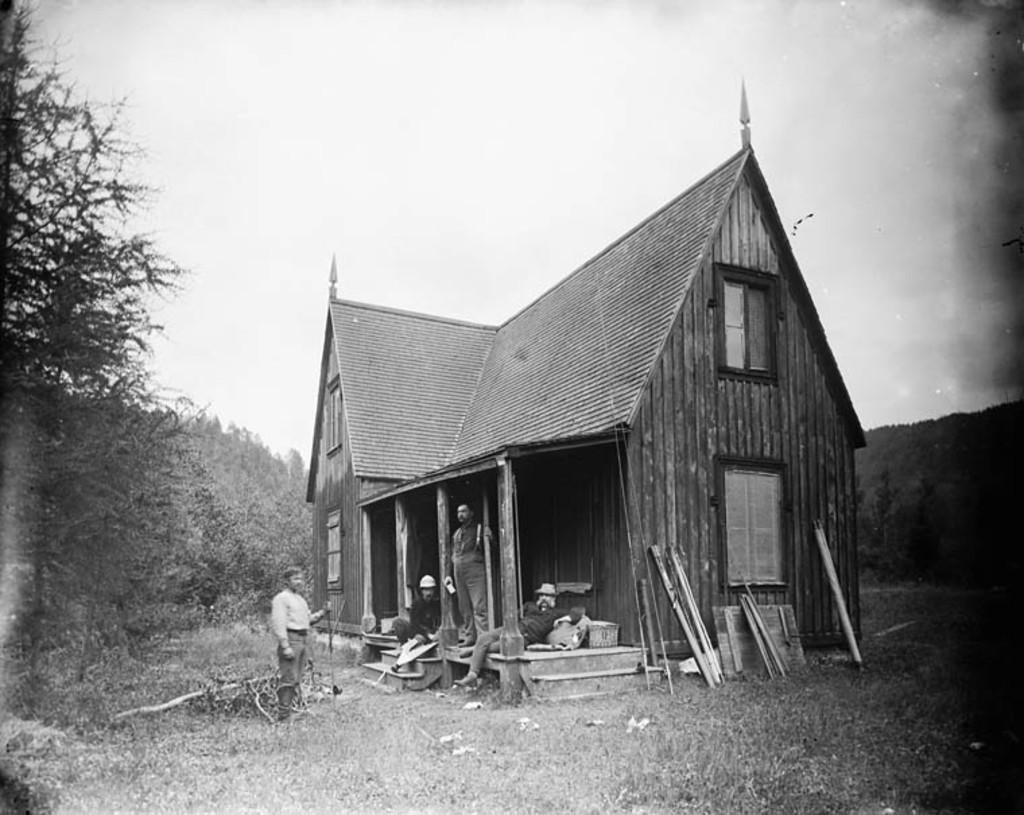Could you give a brief overview of what you see in this image? Here in this picture we can see a house present on the ground over there and in front of it we can see people sitting and standing over there and we can see windows present on the house and we can also see some wooden planks present over there and we can see plants and trees all around it over there. 